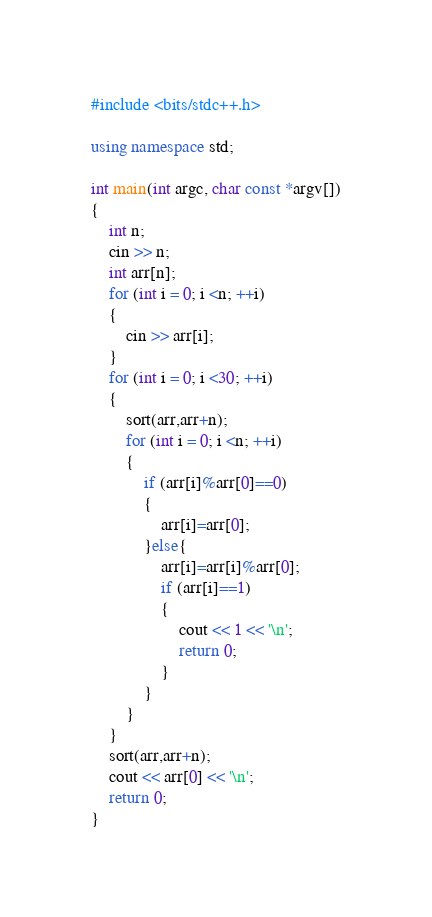Convert code to text. <code><loc_0><loc_0><loc_500><loc_500><_C++_>#include <bits/stdc++.h>
 
using namespace std;
 
int main(int argc, char const *argv[])
{
	int n;
	cin >> n;
	int arr[n];
	for (int i = 0; i <n; ++i)
	{
		cin >> arr[i];
	}
	for (int i = 0; i <30; ++i)
	{
		sort(arr,arr+n);
		for (int i = 0; i <n; ++i)
		{
			if (arr[i]%arr[0]==0)
			{
				arr[i]=arr[0];
			}else{
				arr[i]=arr[i]%arr[0];
				if (arr[i]==1)
				{
					cout << 1 << '\n';
					return 0;
				}
			}
		}
	}
	sort(arr,arr+n);
	cout << arr[0] << '\n';
	return 0;
}</code> 